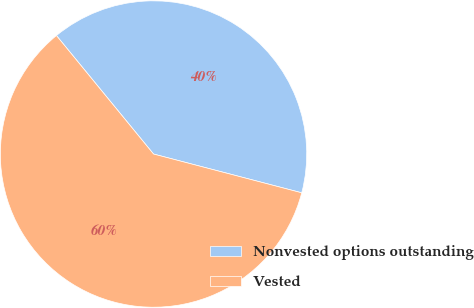Convert chart. <chart><loc_0><loc_0><loc_500><loc_500><pie_chart><fcel>Nonvested options outstanding<fcel>Vested<nl><fcel>40.0%<fcel>60.0%<nl></chart> 